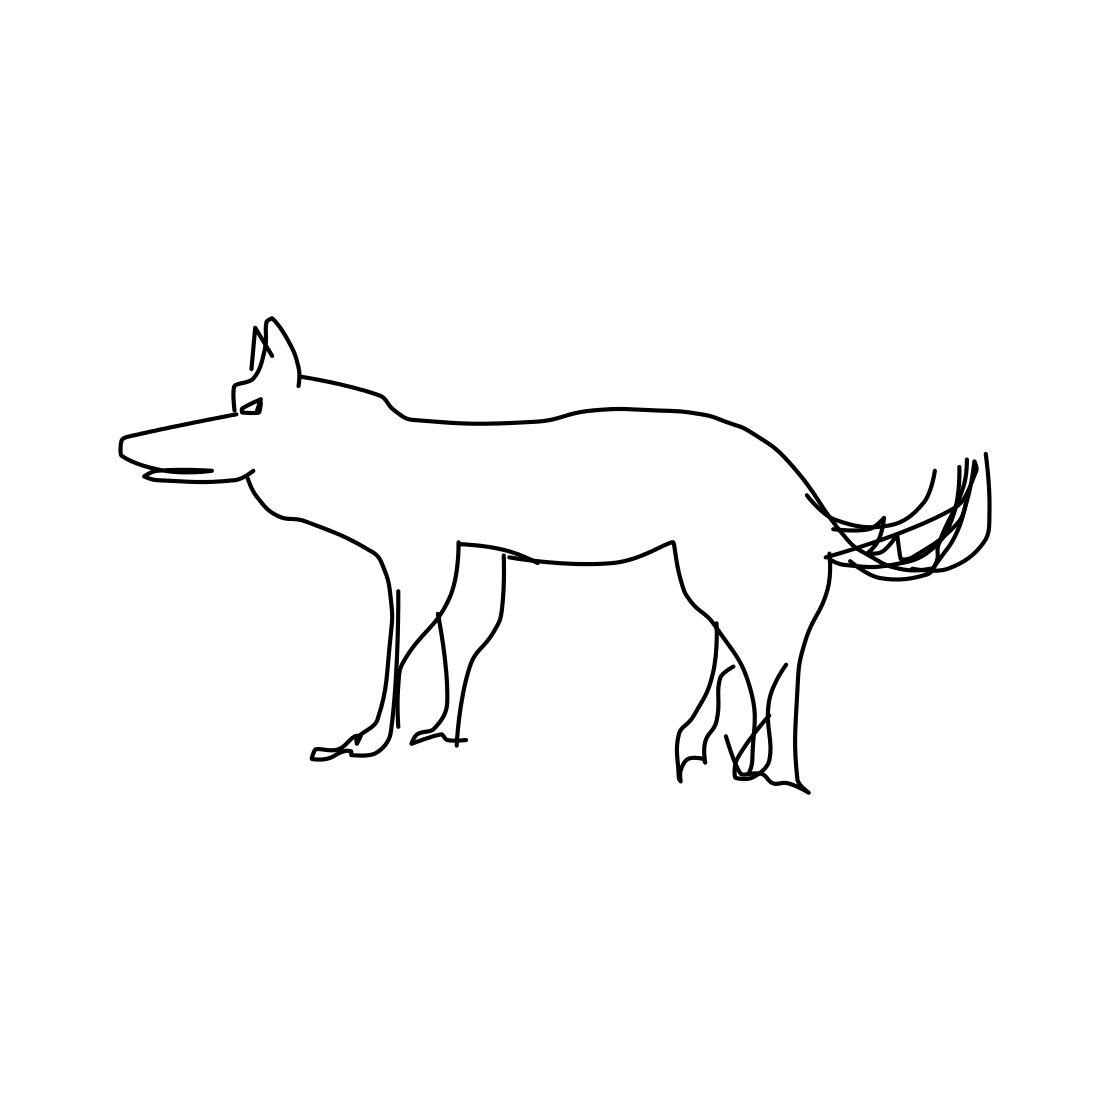In the scene, is a dog in it? Yes 